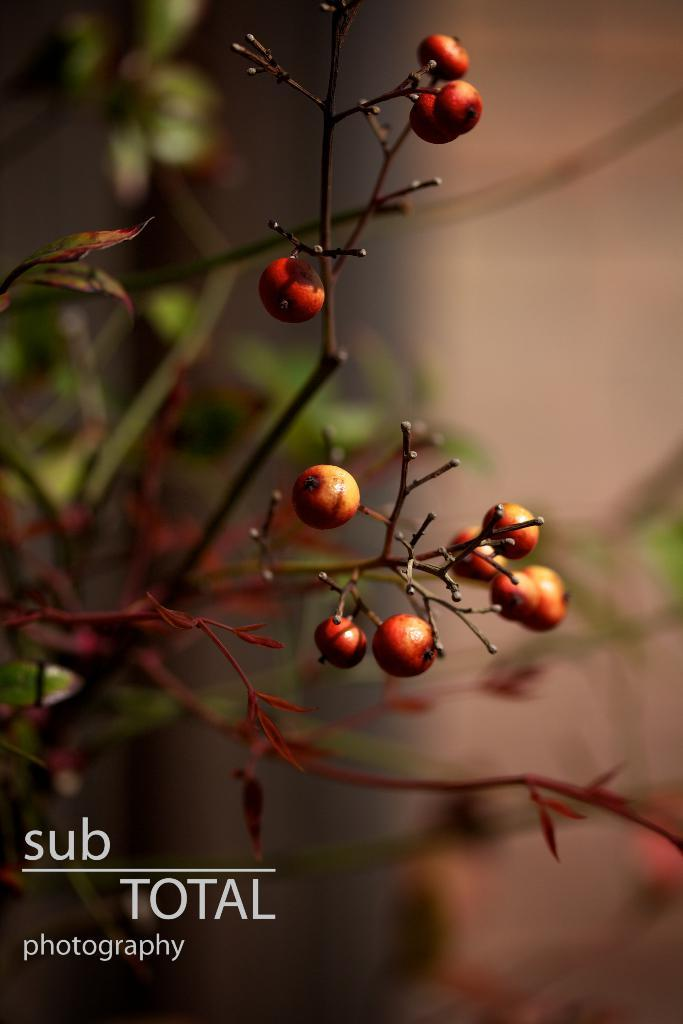What type of food can be seen in the image? There are fruits in the image. Can you describe any additional elements in the image? There is a watermark on the left side of the image. What type of skirt is visible in the image? There is no skirt present in the image. Is there a notebook featured in the image? There is no notebook present in the image. 